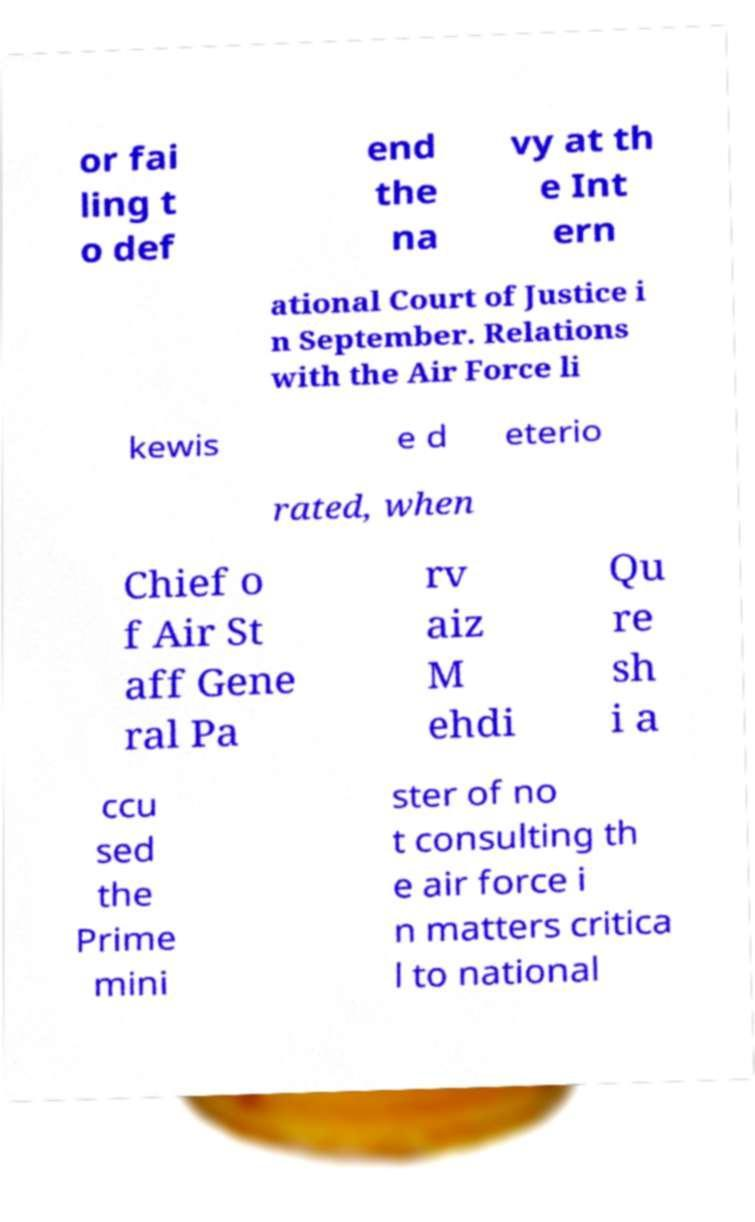There's text embedded in this image that I need extracted. Can you transcribe it verbatim? or fai ling t o def end the na vy at th e Int ern ational Court of Justice i n September. Relations with the Air Force li kewis e d eterio rated, when Chief o f Air St aff Gene ral Pa rv aiz M ehdi Qu re sh i a ccu sed the Prime mini ster of no t consulting th e air force i n matters critica l to national 